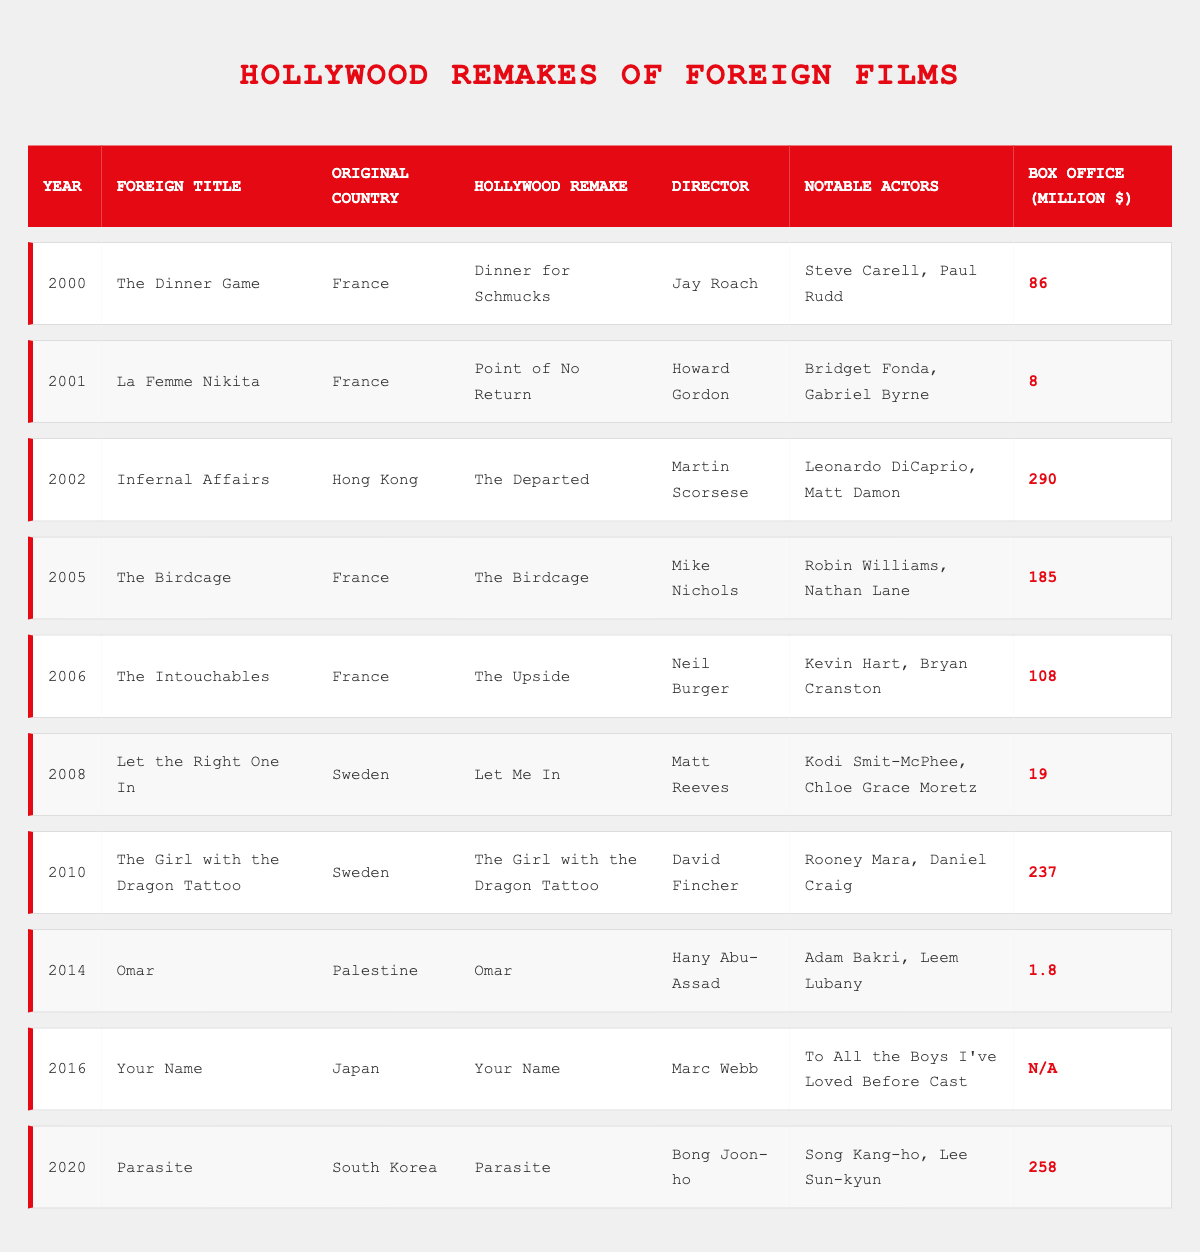What is the highest box office gross for a Hollywood remake of a foreign film? In the table, the box office grosses are listed for each remake. The highest value is under the "The Departed" in 2002, with a gross of 290 million dollars.
Answer: 290 million dollars How many remakes of French films are listed in the table? The table shows several remakes from various countries. Upon reviewing, the films "The Dinner Game," "La Femme Nikita," "The Birdcage," and "The Intouchables" are all French remakes, totaling four.
Answer: 4 Which Hollywood remake has the lowest box office gross? By examining the box office data provided in the table, "Omar" from 2014 has the lowest gross at 1.8 million dollars, which is less than any other listed film.
Answer: 1.8 million dollars Did any of the foreign titles listed have the same title as their Hollywood remake? The table indicates that "The Birdcage" in 2005 and "The Girl with the Dragon Tattoo" in 2010 maintained the same title as their foreign counterpart, confirming that there were two instances.
Answer: Yes What is the average box office gross for the remakes of films released before 2010? The qualifying films for this calculation are "Dinner for Schmucks" (86), "Point of No Return" (8), "The Departed" (290), "The Birdcage" (185), "The Upside" (108), "Let Me In" (19), and "Omar" (1.8), leading to a total of 697 million dollars. Dividing by the 7 films gives an average of approximately 99.57 million dollars.
Answer: Approximately 99.57 million dollars What year saw the release of the remake "The Upside"? In the table, "The Upside" is listed under the year 2006, confirming its release date.
Answer: 2006 Which foreign country has the most remakes listed in this table? Upon reviewing the original countries of the remakes, France appears four times (2000, 2001, 2005, and 2006), while other countries appear only once. Thus, France has the most remakes featured in the table.
Answer: France Is there a Hollywood remake directed by Martin Scorsese? Yes, the table shows that "The Departed," which is a remake of "Infernal Affairs," was directed by Martin Scorsese, confirming a positive response.
Answer: Yes What is the total box office gross for remakes directed by directors from the USA? The directors from the USA are Jay Roach, Howard Gordon, Martin Scorsese, Mike Nichols, Neil Burger, Matt Reeves, David Fincher, and Marc Webb. Combined, their films "Dinner for Schmucks," "Point of No Return," "The Departed," "The Birdcage," "The Upside," "Let Me In," "The Girl with the Dragon Tattoo," and "Your Name" have box office totals of 86, 8, 290, 185, 108, 19, 237, and not applicable (N/A). Summing the values gives us 929 million.
Answer: 929 million dollars Which notable actor features in the remake of "The Intouchables"? The table lists Kevin Hart and Bryan Cranston as notable actors in the Hollywood remake "The Upside," confirming their participation.
Answer: Kevin Hart, Bryan Cranston How many remakes have a box office gross of over 200 million dollars? The only remakes with a box office gross exceeding 200 million dollars are "The Departed" (290 million) and "The Girl with the Dragon Tattoo" (237 million), which amounts to two remakes reaching this benchmark.
Answer: 2 